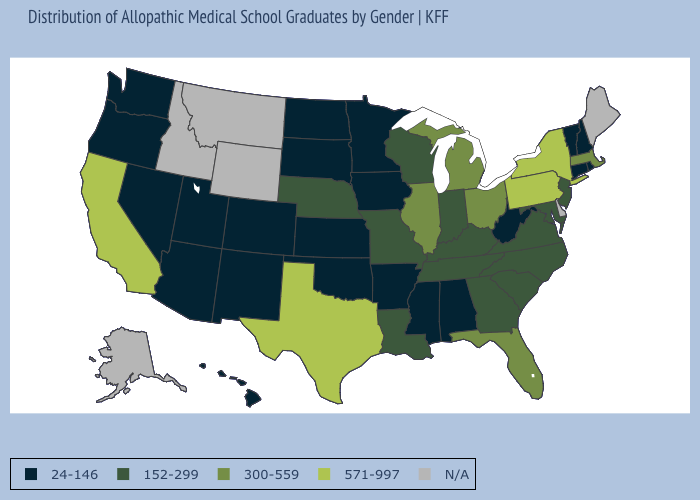Name the states that have a value in the range N/A?
Give a very brief answer. Alaska, Delaware, Idaho, Maine, Montana, Wyoming. Among the states that border New York , does Connecticut have the lowest value?
Concise answer only. Yes. Does New York have the lowest value in the Northeast?
Be succinct. No. Does the map have missing data?
Write a very short answer. Yes. Does the first symbol in the legend represent the smallest category?
Concise answer only. Yes. Does Virginia have the lowest value in the South?
Give a very brief answer. No. How many symbols are there in the legend?
Short answer required. 5. What is the lowest value in states that border Nebraska?
Give a very brief answer. 24-146. What is the value of Alaska?
Quick response, please. N/A. Name the states that have a value in the range N/A?
Answer briefly. Alaska, Delaware, Idaho, Maine, Montana, Wyoming. Among the states that border Vermont , does New Hampshire have the highest value?
Answer briefly. No. Name the states that have a value in the range 571-997?
Quick response, please. California, New York, Pennsylvania, Texas. Which states have the highest value in the USA?
Write a very short answer. California, New York, Pennsylvania, Texas. What is the value of Maine?
Be succinct. N/A. 